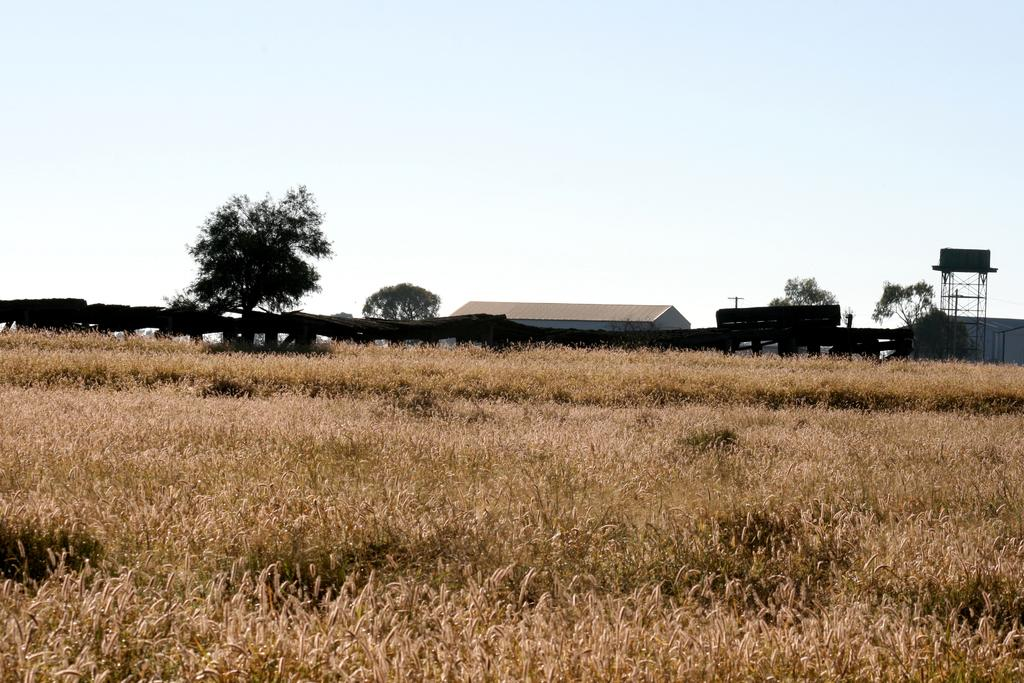What type of landscape is depicted in the image? The image features wheat fields. What can be seen in the background of the image? There are trees, sheds, a tank, and the sky visible in the background of the image. What type of amusement can be seen in the image? There is no amusement present in the image; it features wheat fields, trees, sheds, a tank, and the sky. Can you spot any worms crawling on the wheat in the image? There are no worms visible in the image; it only shows wheat fields, trees, sheds, a tank, and the sky. 